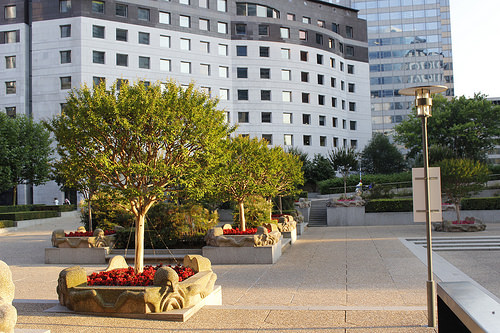<image>
Can you confirm if the tree is in front of the building? Yes. The tree is positioned in front of the building, appearing closer to the camera viewpoint. 